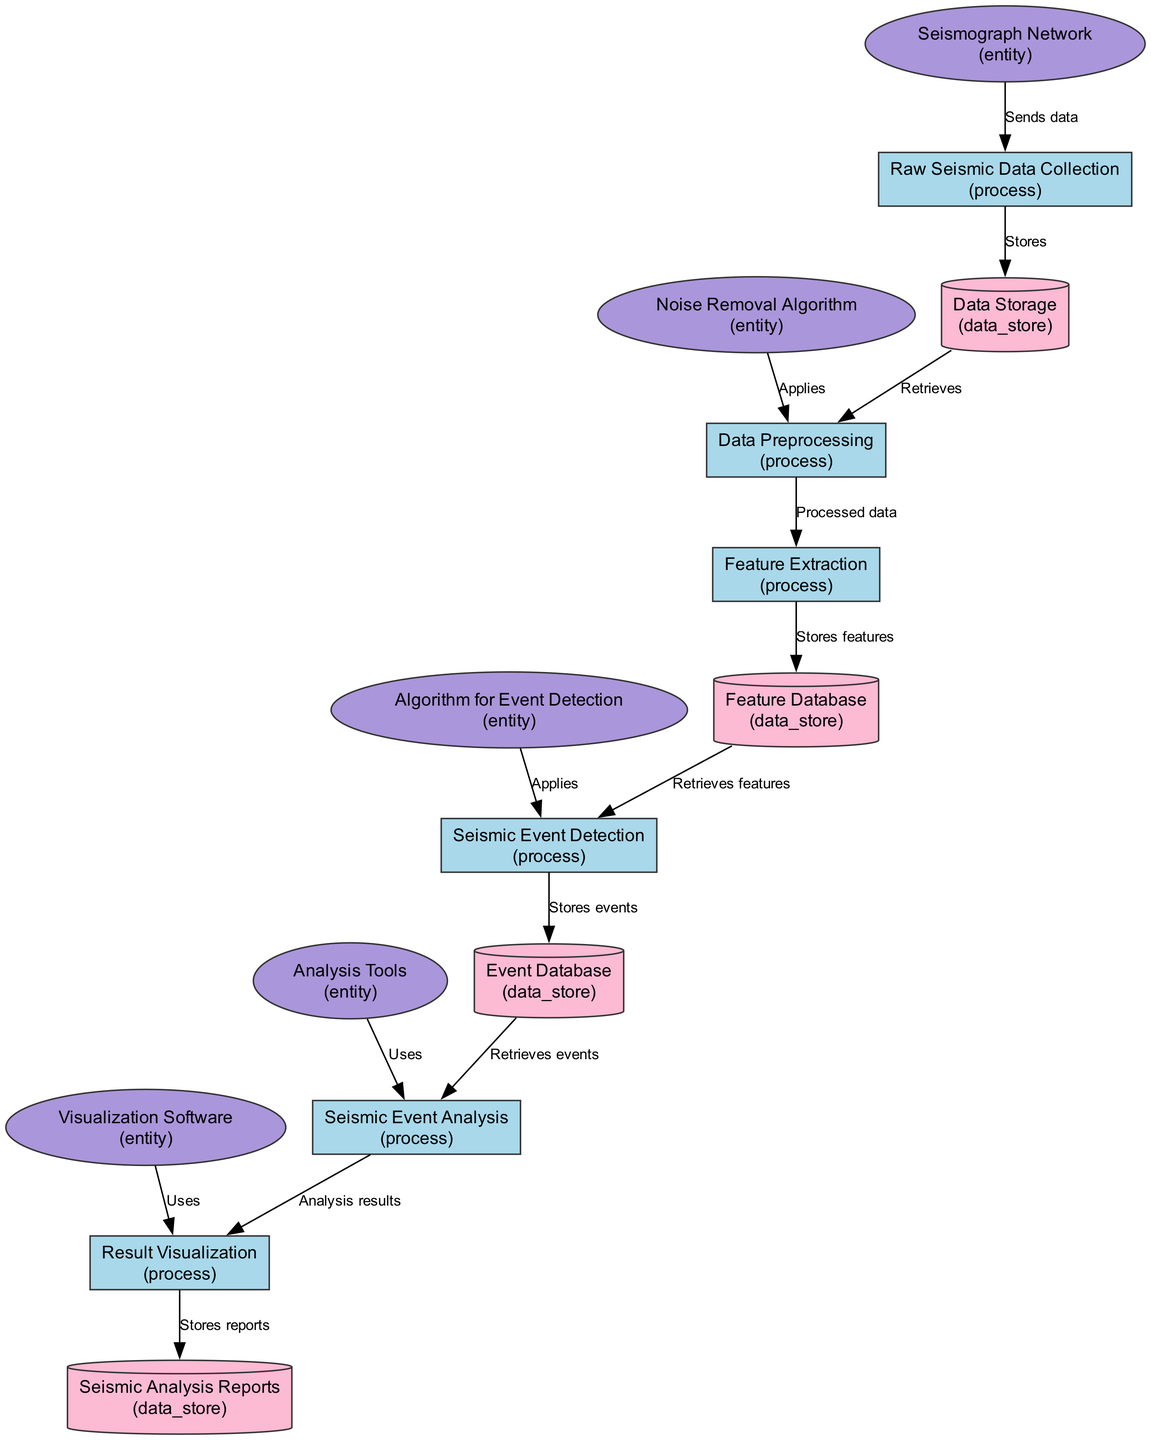What is the first process in the workflow? The first process in the workflow is "Raw Seismic Data Collection," which is indicated by the position in the diagram as the starting point of the data flow.
Answer: Raw Seismic Data Collection How many data stores are present in the diagram? There are five data stores in the diagram: Data Storage, Feature Database, Event Database, Seismic Analysis Reports, and Seismic Event Analysis. Counting these reveals a total of five distinct data stores.
Answer: Five What type of element is "Noise Removal Algorithm"? The "Noise Removal Algorithm" is categorized as an entity according to its description in the diagram. Entities typically represent external systems or components that interact with the processes.
Answer: Entity Which process is responsible for generating visual representations? The process responsible for generating visual representations is "Result Visualization," which specifically outlines the activity of creating graphs, maps, and charts.
Answer: Result Visualization How does "Event Database" receive data? The "Event Database" receives data from the "Seismic Event Detection" process, which stores the detected and classified seismic events directly into the database.
Answer: From Seismic Event Detection What follows the "Data Preprocessing" process? Following the "Data Preprocessing" process, "Feature Extraction" occurs, indicating that processed data is passed on for the extraction of key features necessary for further analysis.
Answer: Feature Extraction What is the final output stored in the workflow? The final output stored in the workflow is "Seismic Analysis Reports," which is where the finalized reports and visualizations are kept for future reference and review.
Answer: Seismic Analysis Reports Which algorithm is used for event detection? The algorithm used for event detection is "Algorithm for Event Detection," which specifies the machine learning or statistical methods employed to identify seismic events.
Answer: Algorithm for Event Detection Which processes are linked to feature extraction? The processes linked to feature extraction include "Data Preprocessing," which prepares the raw data, and the "Seismic Event Detection" process, which retrieves the extracted features for classification.
Answer: Data Preprocessing, Seismic Event Detection 